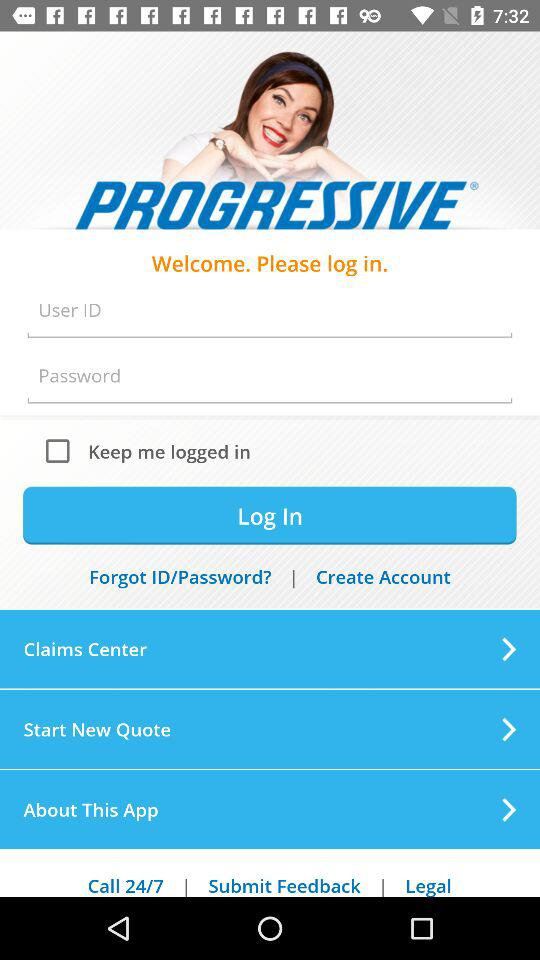What are the requirements to login? The requirements to login are "User ID" and "Password". 